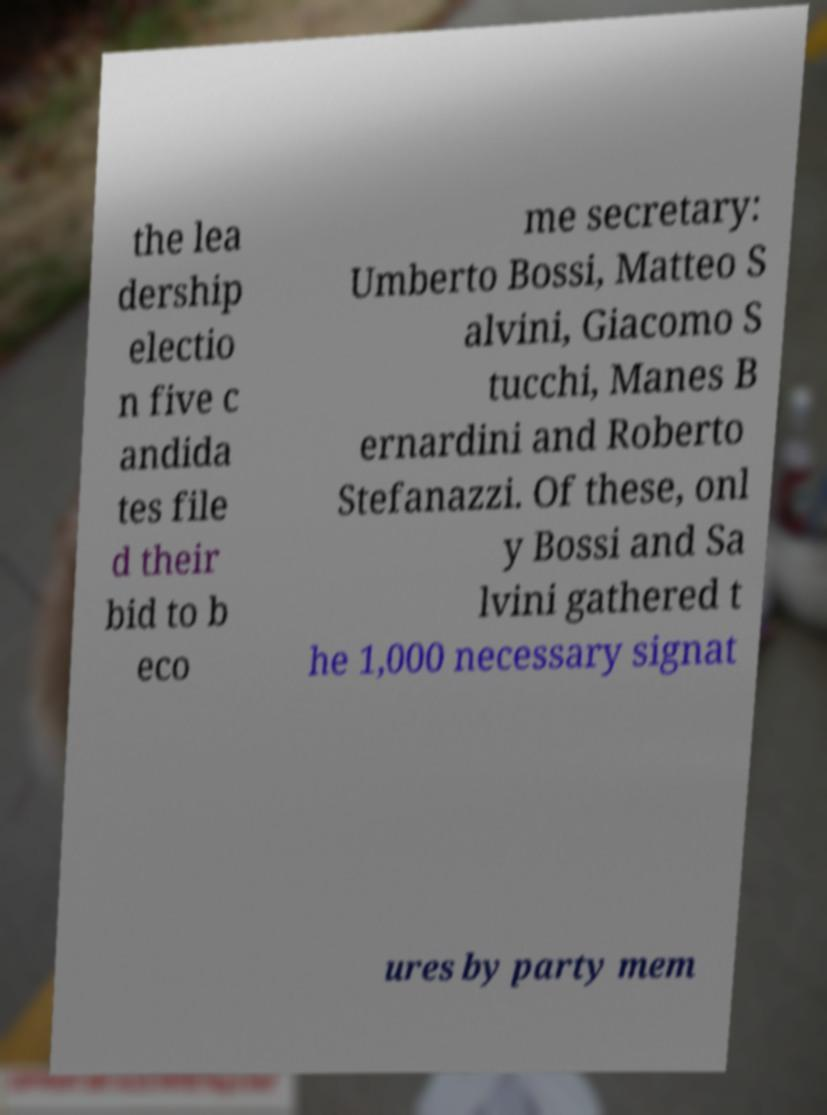There's text embedded in this image that I need extracted. Can you transcribe it verbatim? the lea dership electio n five c andida tes file d their bid to b eco me secretary: Umberto Bossi, Matteo S alvini, Giacomo S tucchi, Manes B ernardini and Roberto Stefanazzi. Of these, onl y Bossi and Sa lvini gathered t he 1,000 necessary signat ures by party mem 